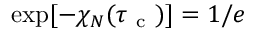<formula> <loc_0><loc_0><loc_500><loc_500>\exp [ - \chi _ { N } ( \tau _ { c } ) ] = 1 / e</formula> 